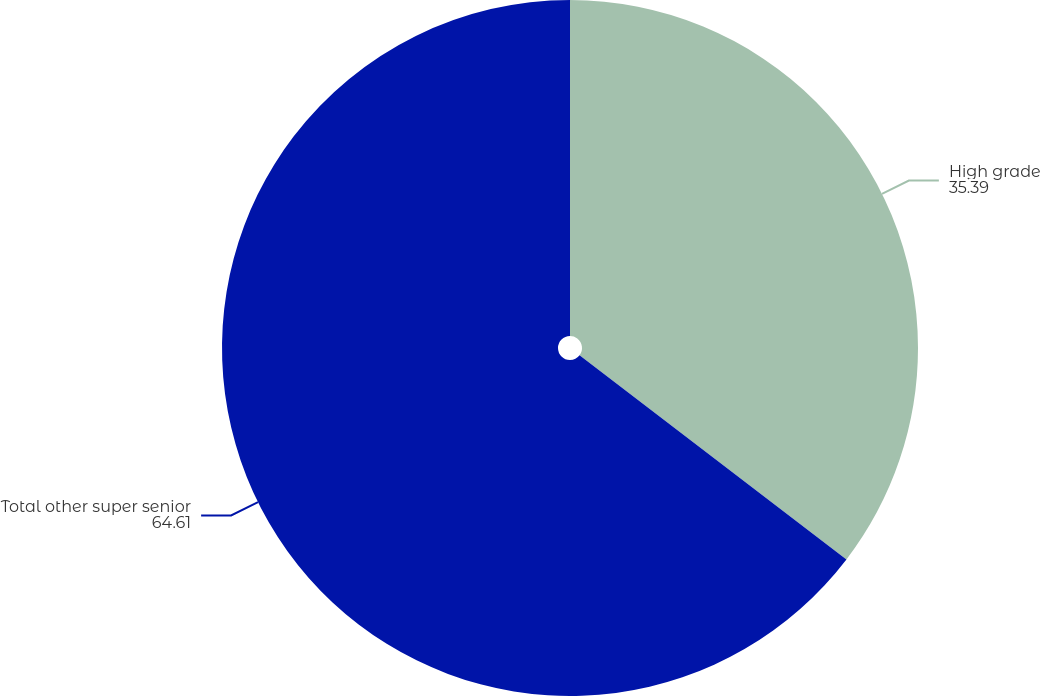<chart> <loc_0><loc_0><loc_500><loc_500><pie_chart><fcel>High grade<fcel>Total other super senior<nl><fcel>35.39%<fcel>64.61%<nl></chart> 